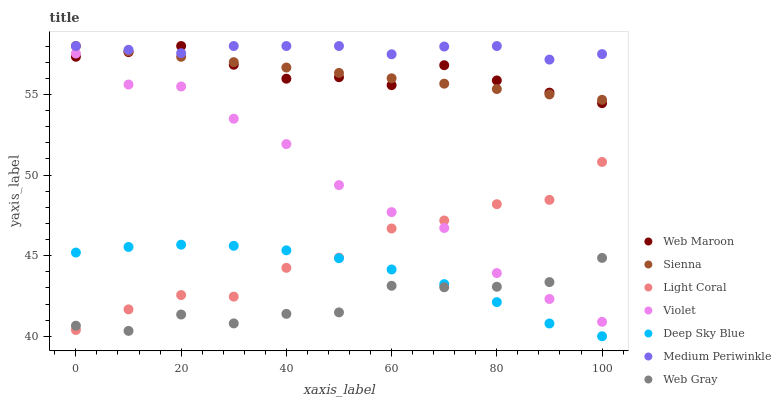Does Web Gray have the minimum area under the curve?
Answer yes or no. Yes. Does Medium Periwinkle have the maximum area under the curve?
Answer yes or no. Yes. Does Medium Periwinkle have the minimum area under the curve?
Answer yes or no. No. Does Web Gray have the maximum area under the curve?
Answer yes or no. No. Is Sienna the smoothest?
Answer yes or no. Yes. Is Light Coral the roughest?
Answer yes or no. Yes. Is Web Gray the smoothest?
Answer yes or no. No. Is Web Gray the roughest?
Answer yes or no. No. Does Deep Sky Blue have the lowest value?
Answer yes or no. Yes. Does Web Gray have the lowest value?
Answer yes or no. No. Does Sienna have the highest value?
Answer yes or no. Yes. Does Web Gray have the highest value?
Answer yes or no. No. Is Deep Sky Blue less than Web Maroon?
Answer yes or no. Yes. Is Medium Periwinkle greater than Light Coral?
Answer yes or no. Yes. Does Violet intersect Web Maroon?
Answer yes or no. Yes. Is Violet less than Web Maroon?
Answer yes or no. No. Is Violet greater than Web Maroon?
Answer yes or no. No. Does Deep Sky Blue intersect Web Maroon?
Answer yes or no. No. 